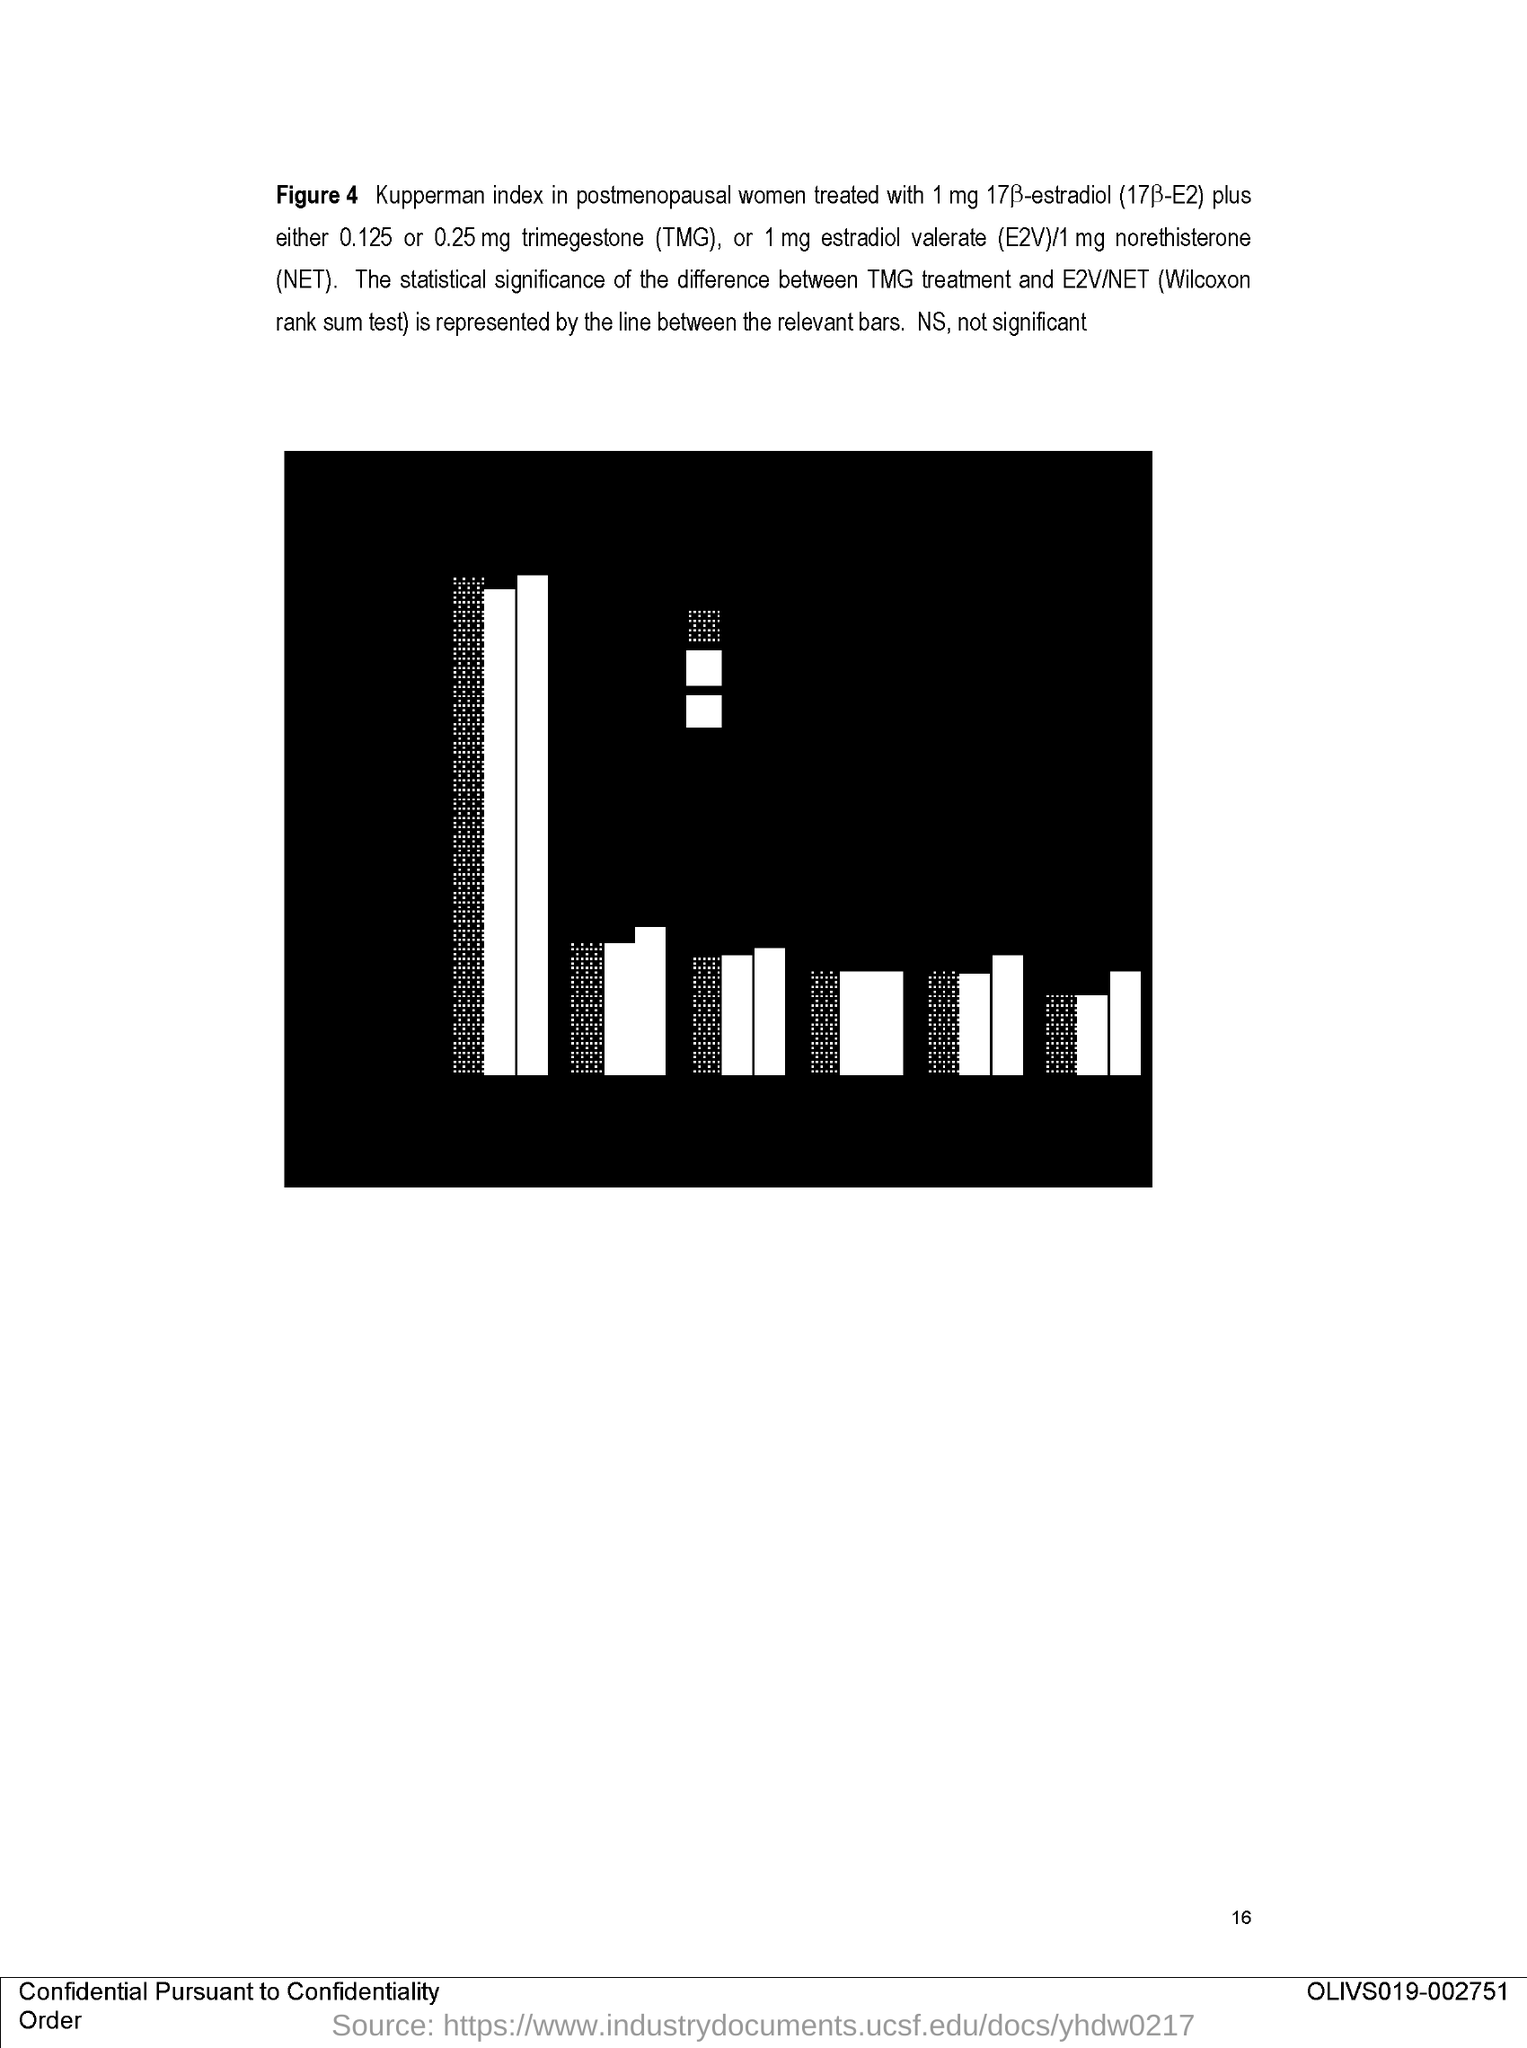What is the "Figure" number of the bar graph?
Offer a very short reply. FIGURE 4. What "index" in postmenopausal women is shown in the graph?
Your response must be concise. KUPPERMAN INDEX. What quantity of estradiol valerate is used for treatment?
Provide a succinct answer. 1 mg. What quantity of norethisterone is used for treatment?
Provide a short and direct response. 1 mg. What is the expansion of TMG?
Your response must be concise. TRIMEGESTONE. What is the expansion of NET?
Your answer should be compact. Norethisterone. What is the name of E2V/NET test?
Offer a very short reply. Wilcoxon rank sum test. What does NS mean?
Your answer should be very brief. Not significant. 